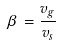Convert formula to latex. <formula><loc_0><loc_0><loc_500><loc_500>\beta = \frac { v _ { g } } { v _ { s } }</formula> 